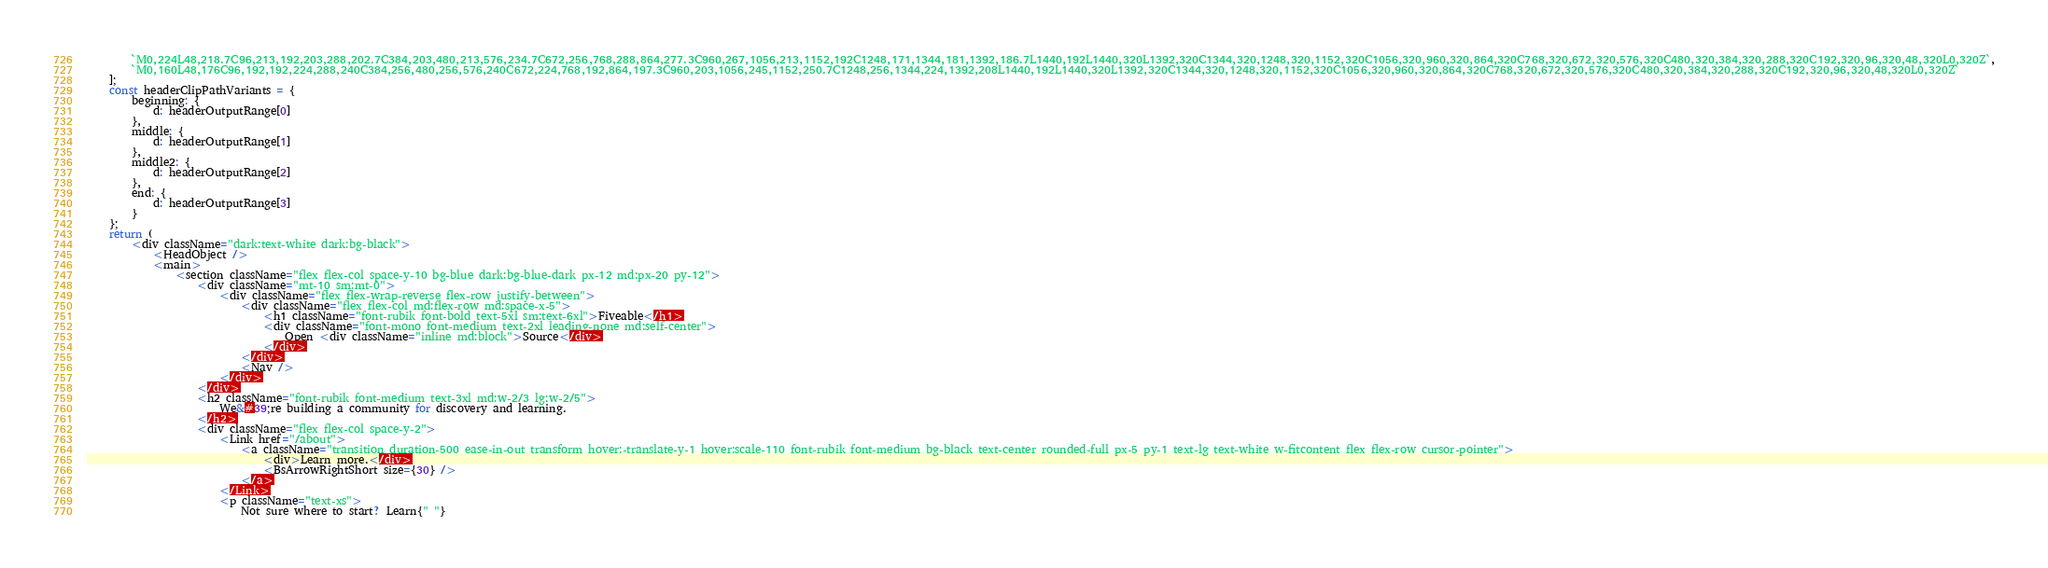<code> <loc_0><loc_0><loc_500><loc_500><_JavaScript_>        `M0,224L48,218.7C96,213,192,203,288,202.7C384,203,480,213,576,234.7C672,256,768,288,864,277.3C960,267,1056,213,1152,192C1248,171,1344,181,1392,186.7L1440,192L1440,320L1392,320C1344,320,1248,320,1152,320C1056,320,960,320,864,320C768,320,672,320,576,320C480,320,384,320,288,320C192,320,96,320,48,320L0,320Z`,
        `M0,160L48,176C96,192,192,224,288,240C384,256,480,256,576,240C672,224,768,192,864,197.3C960,203,1056,245,1152,250.7C1248,256,1344,224,1392,208L1440,192L1440,320L1392,320C1344,320,1248,320,1152,320C1056,320,960,320,864,320C768,320,672,320,576,320C480,320,384,320,288,320C192,320,96,320,48,320L0,320Z`
    ];
    const headerClipPathVariants = {
        beginning: {
            d: headerOutputRange[0]
        },
        middle: {
            d: headerOutputRange[1]
        },
        middle2: {
            d: headerOutputRange[2]
        },
        end: {
            d: headerOutputRange[3]
        }
    };
    return (
        <div className="dark:text-white dark:bg-black">
            <HeadObject />
            <main>
                <section className="flex flex-col space-y-10 bg-blue dark:bg-blue-dark px-12 md:px-20 py-12">
                    <div className="mt-10 sm:mt-0">
                        <div className="flex flex-wrap-reverse flex-row justify-between">
                            <div className="flex flex-col md:flex-row md:space-x-5">
                                <h1 className="font-rubik font-bold text-5xl sm:text-6xl">Fiveable</h1>
                                <div className="font-mono font-medium text-2xl leading-none md:self-center">
                                    Open <div className="inline md:block">Source</div>
                                </div>
                            </div>
                            <Nav />
                        </div>
                    </div>
                    <h2 className="font-rubik font-medium text-3xl md:w-2/3 lg:w-2/5">
                        We&#39;re building a community for discovery and learning.
                    </h2>
                    <div className="flex flex-col space-y-2">
                        <Link href="/about">
                            <a className="transition duration-500 ease-in-out transform hover:-translate-y-1 hover:scale-110 font-rubik font-medium bg-black text-center rounded-full px-5 py-1 text-lg text-white w-fitcontent flex flex-row cursor-pointer">
                                <div>Learn more.</div>
                                <BsArrowRightShort size={30} />
                            </a>
                        </Link>
                        <p className="text-xs">
                            Not sure where to start? Learn{" "}</code> 